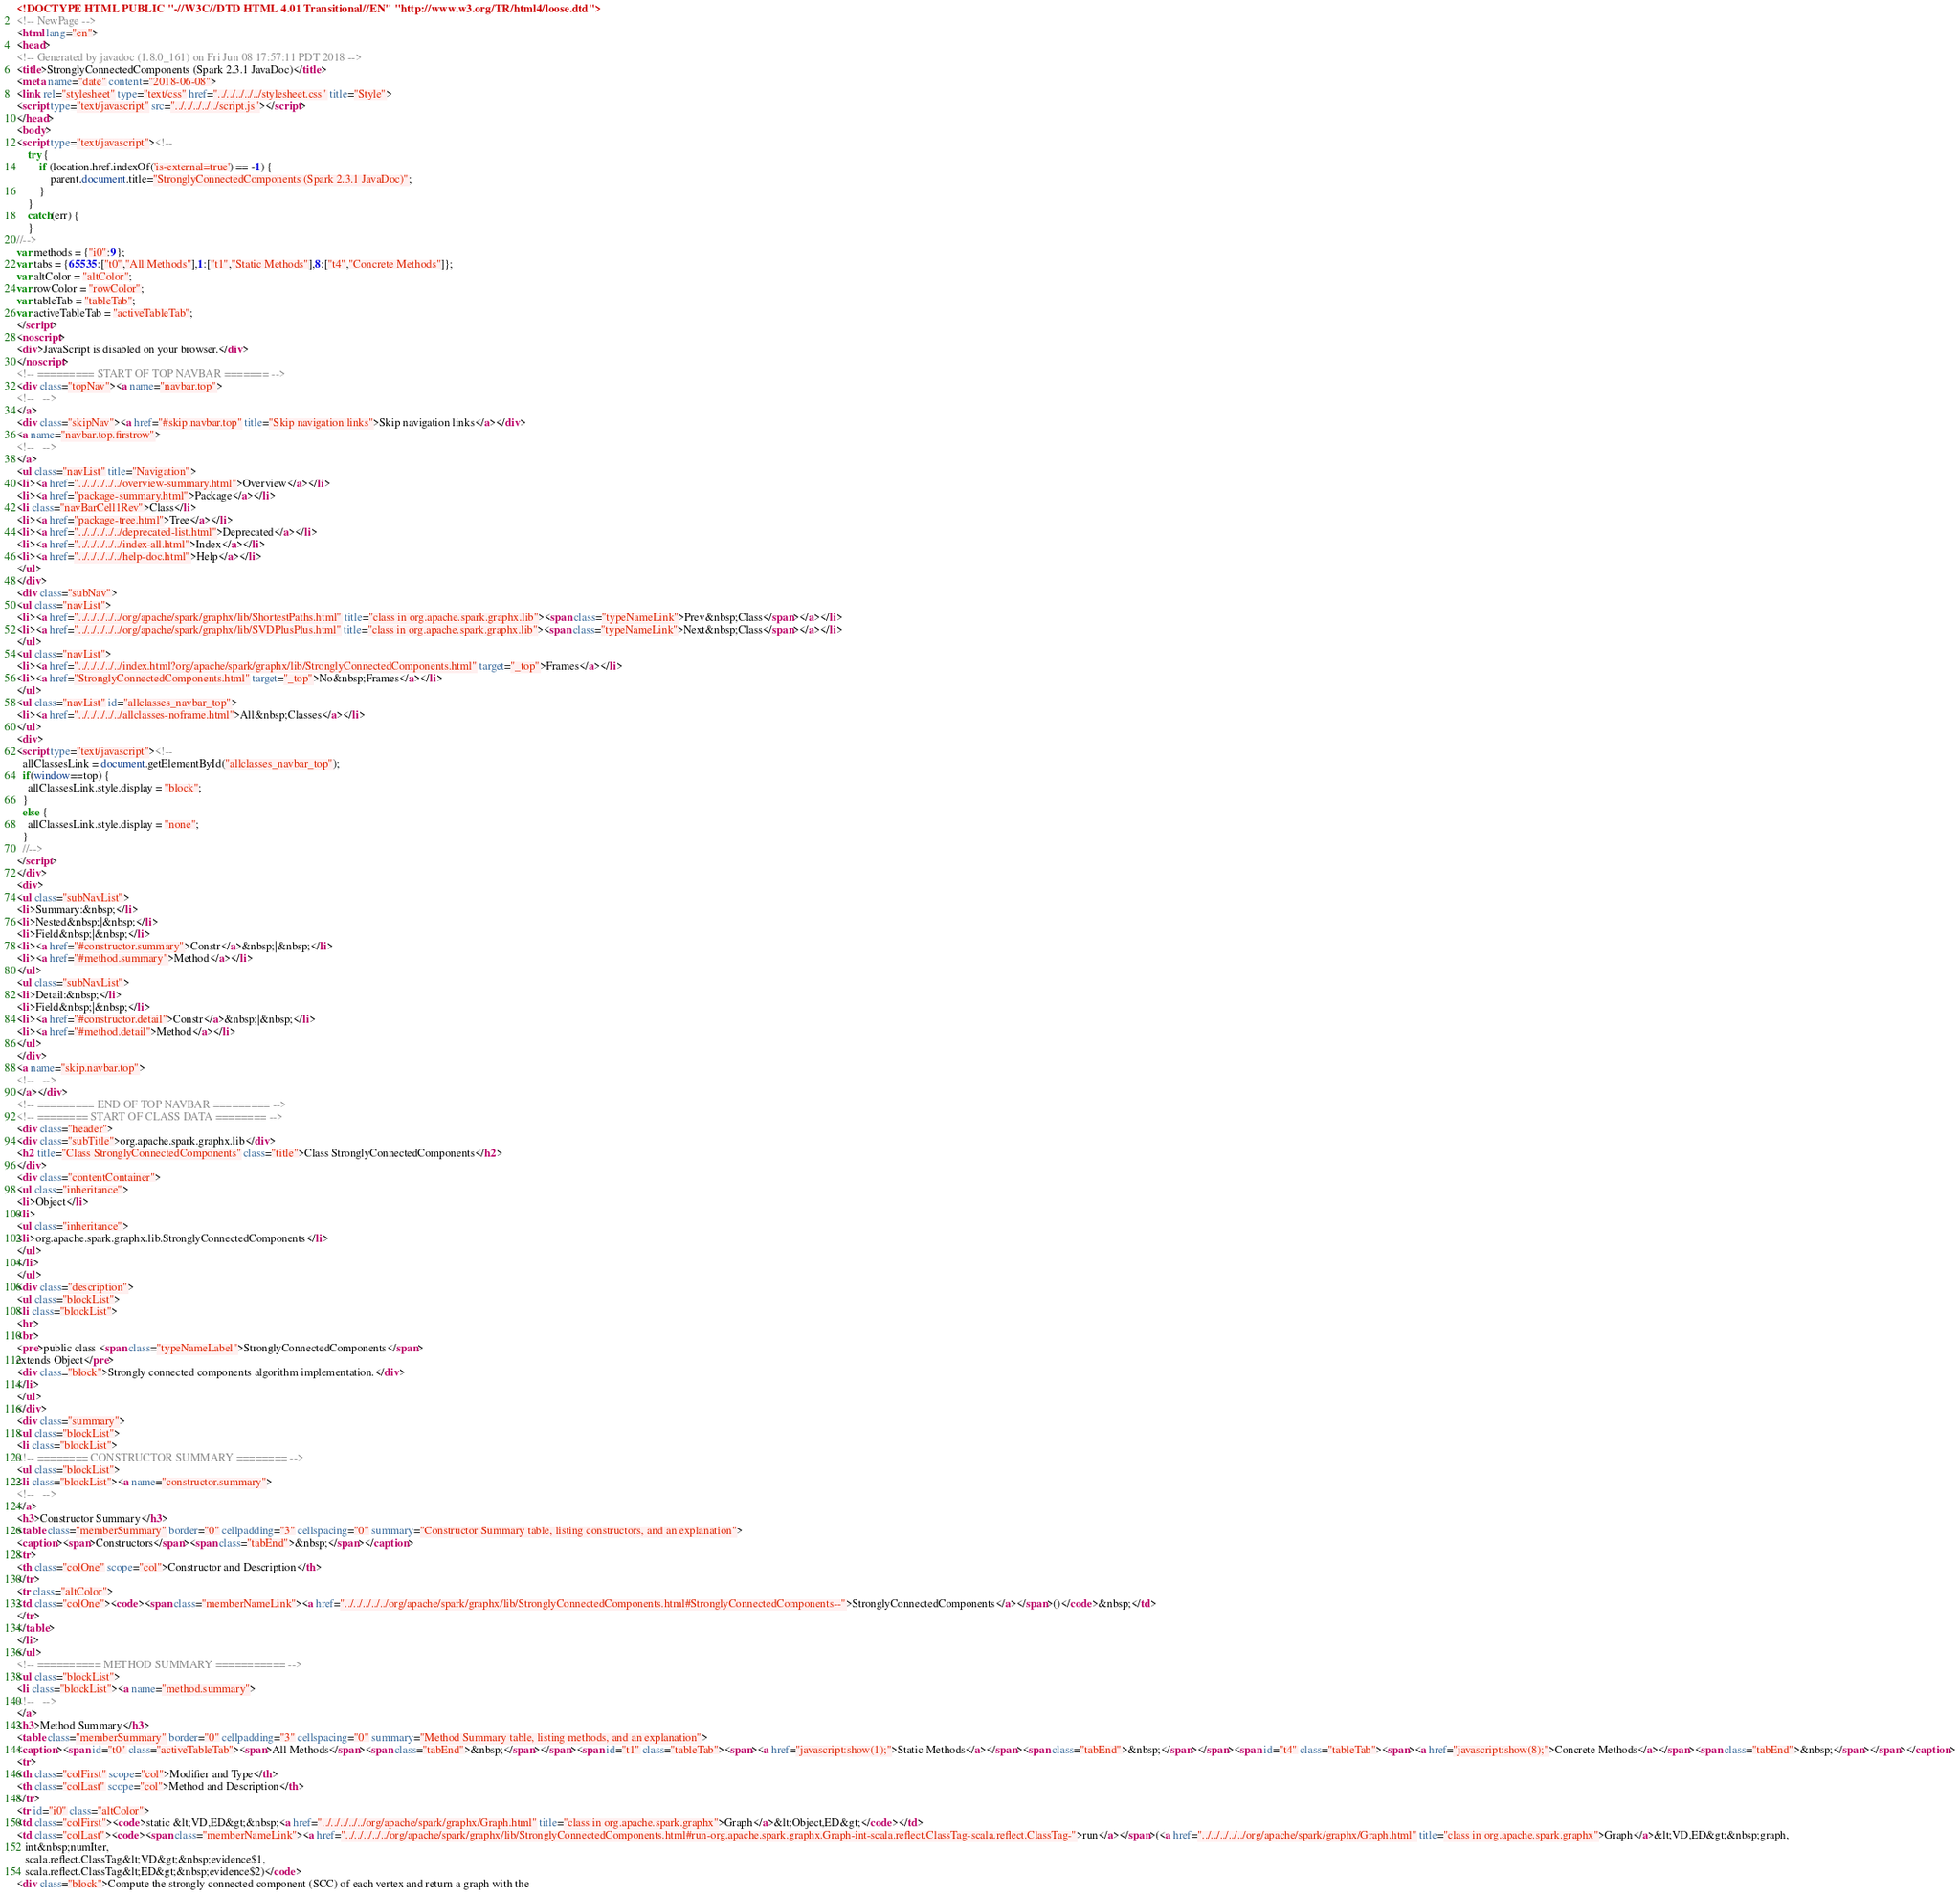Convert code to text. <code><loc_0><loc_0><loc_500><loc_500><_HTML_><!DOCTYPE HTML PUBLIC "-//W3C//DTD HTML 4.01 Transitional//EN" "http://www.w3.org/TR/html4/loose.dtd">
<!-- NewPage -->
<html lang="en">
<head>
<!-- Generated by javadoc (1.8.0_161) on Fri Jun 08 17:57:11 PDT 2018 -->
<title>StronglyConnectedComponents (Spark 2.3.1 JavaDoc)</title>
<meta name="date" content="2018-06-08">
<link rel="stylesheet" type="text/css" href="../../../../../stylesheet.css" title="Style">
<script type="text/javascript" src="../../../../../script.js"></script>
</head>
<body>
<script type="text/javascript"><!--
    try {
        if (location.href.indexOf('is-external=true') == -1) {
            parent.document.title="StronglyConnectedComponents (Spark 2.3.1 JavaDoc)";
        }
    }
    catch(err) {
    }
//-->
var methods = {"i0":9};
var tabs = {65535:["t0","All Methods"],1:["t1","Static Methods"],8:["t4","Concrete Methods"]};
var altColor = "altColor";
var rowColor = "rowColor";
var tableTab = "tableTab";
var activeTableTab = "activeTableTab";
</script>
<noscript>
<div>JavaScript is disabled on your browser.</div>
</noscript>
<!-- ========= START OF TOP NAVBAR ======= -->
<div class="topNav"><a name="navbar.top">
<!--   -->
</a>
<div class="skipNav"><a href="#skip.navbar.top" title="Skip navigation links">Skip navigation links</a></div>
<a name="navbar.top.firstrow">
<!--   -->
</a>
<ul class="navList" title="Navigation">
<li><a href="../../../../../overview-summary.html">Overview</a></li>
<li><a href="package-summary.html">Package</a></li>
<li class="navBarCell1Rev">Class</li>
<li><a href="package-tree.html">Tree</a></li>
<li><a href="../../../../../deprecated-list.html">Deprecated</a></li>
<li><a href="../../../../../index-all.html">Index</a></li>
<li><a href="../../../../../help-doc.html">Help</a></li>
</ul>
</div>
<div class="subNav">
<ul class="navList">
<li><a href="../../../../../org/apache/spark/graphx/lib/ShortestPaths.html" title="class in org.apache.spark.graphx.lib"><span class="typeNameLink">Prev&nbsp;Class</span></a></li>
<li><a href="../../../../../org/apache/spark/graphx/lib/SVDPlusPlus.html" title="class in org.apache.spark.graphx.lib"><span class="typeNameLink">Next&nbsp;Class</span></a></li>
</ul>
<ul class="navList">
<li><a href="../../../../../index.html?org/apache/spark/graphx/lib/StronglyConnectedComponents.html" target="_top">Frames</a></li>
<li><a href="StronglyConnectedComponents.html" target="_top">No&nbsp;Frames</a></li>
</ul>
<ul class="navList" id="allclasses_navbar_top">
<li><a href="../../../../../allclasses-noframe.html">All&nbsp;Classes</a></li>
</ul>
<div>
<script type="text/javascript"><!--
  allClassesLink = document.getElementById("allclasses_navbar_top");
  if(window==top) {
    allClassesLink.style.display = "block";
  }
  else {
    allClassesLink.style.display = "none";
  }
  //-->
</script>
</div>
<div>
<ul class="subNavList">
<li>Summary:&nbsp;</li>
<li>Nested&nbsp;|&nbsp;</li>
<li>Field&nbsp;|&nbsp;</li>
<li><a href="#constructor.summary">Constr</a>&nbsp;|&nbsp;</li>
<li><a href="#method.summary">Method</a></li>
</ul>
<ul class="subNavList">
<li>Detail:&nbsp;</li>
<li>Field&nbsp;|&nbsp;</li>
<li><a href="#constructor.detail">Constr</a>&nbsp;|&nbsp;</li>
<li><a href="#method.detail">Method</a></li>
</ul>
</div>
<a name="skip.navbar.top">
<!--   -->
</a></div>
<!-- ========= END OF TOP NAVBAR ========= -->
<!-- ======== START OF CLASS DATA ======== -->
<div class="header">
<div class="subTitle">org.apache.spark.graphx.lib</div>
<h2 title="Class StronglyConnectedComponents" class="title">Class StronglyConnectedComponents</h2>
</div>
<div class="contentContainer">
<ul class="inheritance">
<li>Object</li>
<li>
<ul class="inheritance">
<li>org.apache.spark.graphx.lib.StronglyConnectedComponents</li>
</ul>
</li>
</ul>
<div class="description">
<ul class="blockList">
<li class="blockList">
<hr>
<br>
<pre>public class <span class="typeNameLabel">StronglyConnectedComponents</span>
extends Object</pre>
<div class="block">Strongly connected components algorithm implementation.</div>
</li>
</ul>
</div>
<div class="summary">
<ul class="blockList">
<li class="blockList">
<!-- ======== CONSTRUCTOR SUMMARY ======== -->
<ul class="blockList">
<li class="blockList"><a name="constructor.summary">
<!--   -->
</a>
<h3>Constructor Summary</h3>
<table class="memberSummary" border="0" cellpadding="3" cellspacing="0" summary="Constructor Summary table, listing constructors, and an explanation">
<caption><span>Constructors</span><span class="tabEnd">&nbsp;</span></caption>
<tr>
<th class="colOne" scope="col">Constructor and Description</th>
</tr>
<tr class="altColor">
<td class="colOne"><code><span class="memberNameLink"><a href="../../../../../org/apache/spark/graphx/lib/StronglyConnectedComponents.html#StronglyConnectedComponents--">StronglyConnectedComponents</a></span>()</code>&nbsp;</td>
</tr>
</table>
</li>
</ul>
<!-- ========== METHOD SUMMARY =========== -->
<ul class="blockList">
<li class="blockList"><a name="method.summary">
<!--   -->
</a>
<h3>Method Summary</h3>
<table class="memberSummary" border="0" cellpadding="3" cellspacing="0" summary="Method Summary table, listing methods, and an explanation">
<caption><span id="t0" class="activeTableTab"><span>All Methods</span><span class="tabEnd">&nbsp;</span></span><span id="t1" class="tableTab"><span><a href="javascript:show(1);">Static Methods</a></span><span class="tabEnd">&nbsp;</span></span><span id="t4" class="tableTab"><span><a href="javascript:show(8);">Concrete Methods</a></span><span class="tabEnd">&nbsp;</span></span></caption>
<tr>
<th class="colFirst" scope="col">Modifier and Type</th>
<th class="colLast" scope="col">Method and Description</th>
</tr>
<tr id="i0" class="altColor">
<td class="colFirst"><code>static &lt;VD,ED&gt;&nbsp;<a href="../../../../../org/apache/spark/graphx/Graph.html" title="class in org.apache.spark.graphx">Graph</a>&lt;Object,ED&gt;</code></td>
<td class="colLast"><code><span class="memberNameLink"><a href="../../../../../org/apache/spark/graphx/lib/StronglyConnectedComponents.html#run-org.apache.spark.graphx.Graph-int-scala.reflect.ClassTag-scala.reflect.ClassTag-">run</a></span>(<a href="../../../../../org/apache/spark/graphx/Graph.html" title="class in org.apache.spark.graphx">Graph</a>&lt;VD,ED&gt;&nbsp;graph,
   int&nbsp;numIter,
   scala.reflect.ClassTag&lt;VD&gt;&nbsp;evidence$1,
   scala.reflect.ClassTag&lt;ED&gt;&nbsp;evidence$2)</code>
<div class="block">Compute the strongly connected component (SCC) of each vertex and return a graph with the</code> 